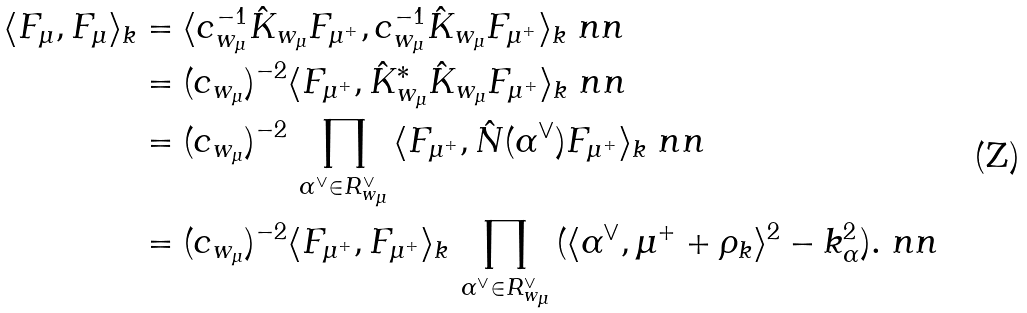Convert formula to latex. <formula><loc_0><loc_0><loc_500><loc_500>\langle F _ { \mu } , F _ { \mu } \rangle _ { k } & = \langle c _ { w _ { \mu } } ^ { - 1 } \hat { K } _ { w _ { \mu } } F _ { \mu ^ { + } } , c _ { w _ { \mu } } ^ { - 1 } \hat { K } _ { w _ { \mu } } F _ { \mu ^ { + } } \rangle _ { k } \ n n \\ & = ( c _ { w _ { \mu } } ) ^ { - 2 } \langle F _ { \mu ^ { + } } , \hat { K } _ { w _ { \mu } } ^ { * } \hat { K } _ { w _ { \mu } } F _ { \mu ^ { + } } \rangle _ { k } \ n n \\ & = ( c _ { w _ { \mu } } ) ^ { - 2 } \, \prod _ { \alpha ^ { \vee } \in R _ { w _ { \mu } } ^ { \vee } } \, \langle F _ { \mu ^ { + } } , \hat { N } ( \alpha ^ { \vee } ) F _ { \mu ^ { + } } \rangle _ { k } \ n n \\ & = ( c _ { w _ { \mu } } ) ^ { - 2 } \langle F _ { \mu ^ { + } } , F _ { \mu ^ { + } } \rangle _ { k } \, \prod _ { \alpha ^ { \vee } \in R _ { w _ { \mu } } ^ { \vee } } \, ( \langle \alpha ^ { \vee } , \mu ^ { + } + \rho _ { k } \rangle ^ { 2 } - k _ { \alpha } ^ { 2 } ) . \ n n</formula> 